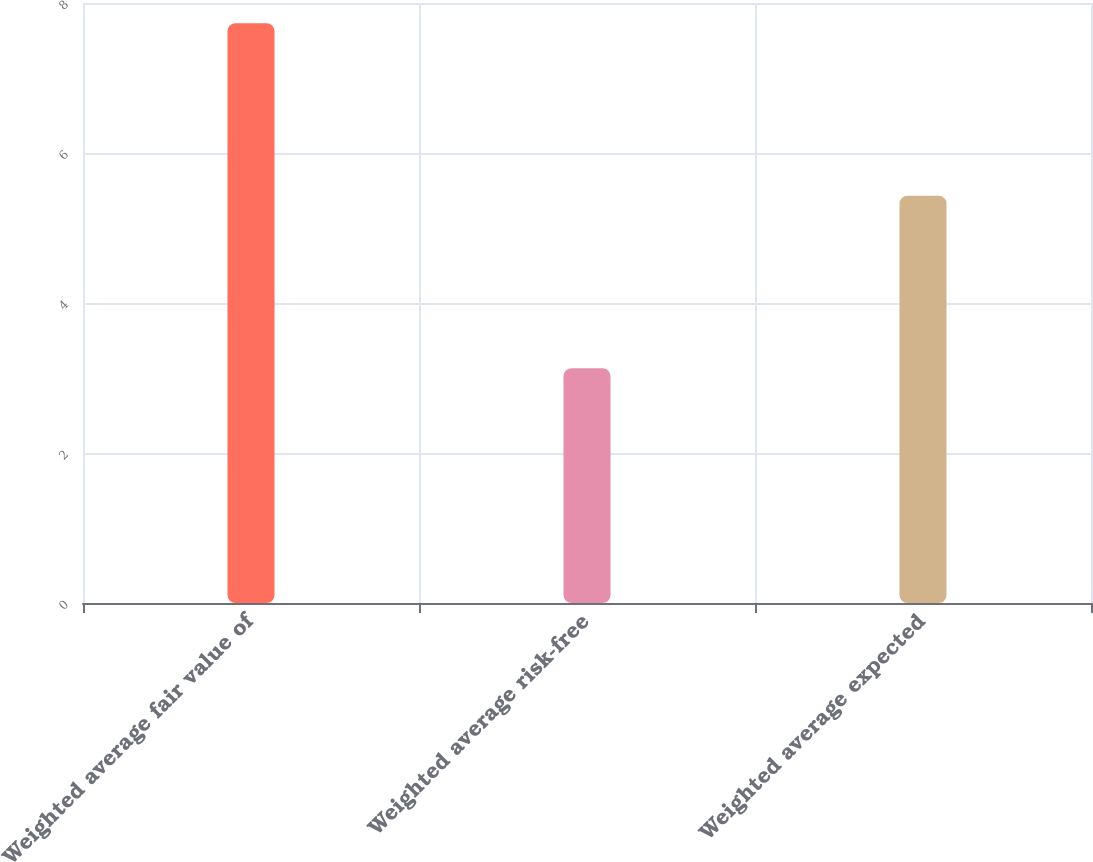<chart> <loc_0><loc_0><loc_500><loc_500><bar_chart><fcel>Weighted average fair value of<fcel>Weighted average risk-free<fcel>Weighted average expected<nl><fcel>7.73<fcel>3.13<fcel>5.43<nl></chart> 